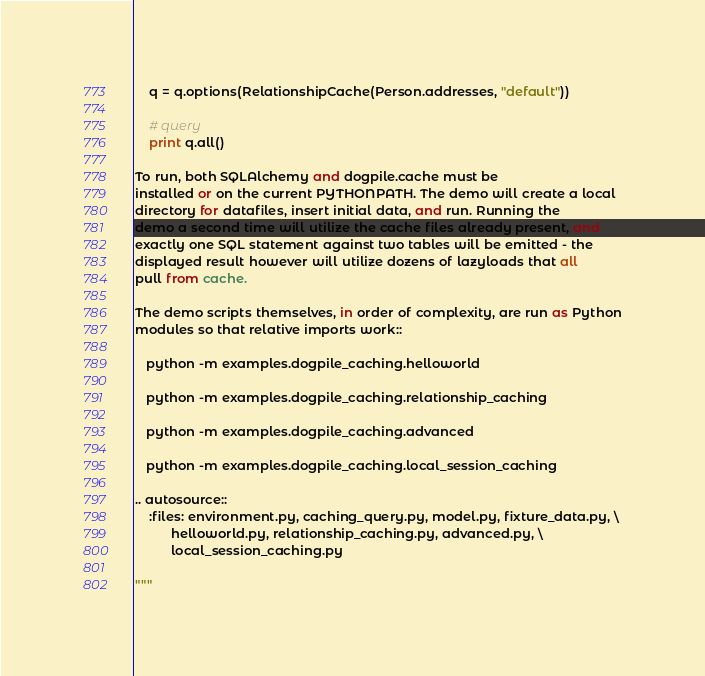<code> <loc_0><loc_0><loc_500><loc_500><_Python_>    q = q.options(RelationshipCache(Person.addresses, "default"))

    # query
    print q.all()

To run, both SQLAlchemy and dogpile.cache must be
installed or on the current PYTHONPATH. The demo will create a local
directory for datafiles, insert initial data, and run. Running the
demo a second time will utilize the cache files already present, and
exactly one SQL statement against two tables will be emitted - the
displayed result however will utilize dozens of lazyloads that all
pull from cache.

The demo scripts themselves, in order of complexity, are run as Python
modules so that relative imports work::

   python -m examples.dogpile_caching.helloworld

   python -m examples.dogpile_caching.relationship_caching

   python -m examples.dogpile_caching.advanced

   python -m examples.dogpile_caching.local_session_caching

.. autosource::
    :files: environment.py, caching_query.py, model.py, fixture_data.py, \
          helloworld.py, relationship_caching.py, advanced.py, \
          local_session_caching.py

"""
</code> 